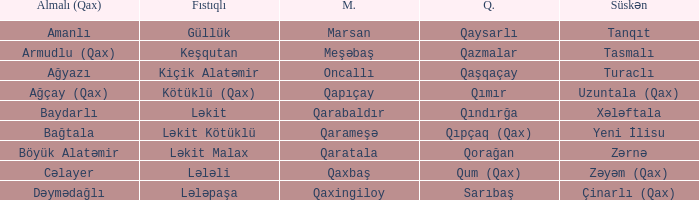What is the Süskən village with a Malax village meşəbaş? Tasmalı. 